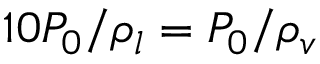<formula> <loc_0><loc_0><loc_500><loc_500>1 0 P _ { 0 } / \rho _ { l } = P _ { 0 } / \rho _ { v }</formula> 